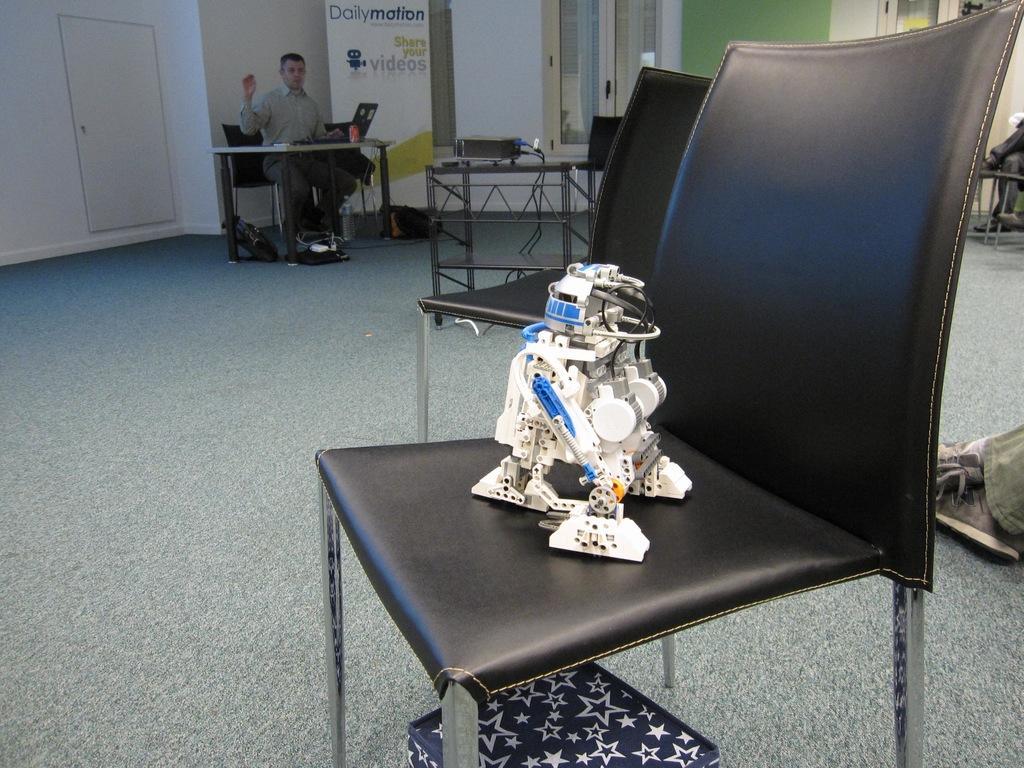How would you summarize this image in a sentence or two? In this image, There is a floor which is in gray color, In the middle there is a chair which is in black color on that chair there is a white color object, In the background there is a man sitting on the chair and there is a table which is in white color, There is a wall and door in white color. 